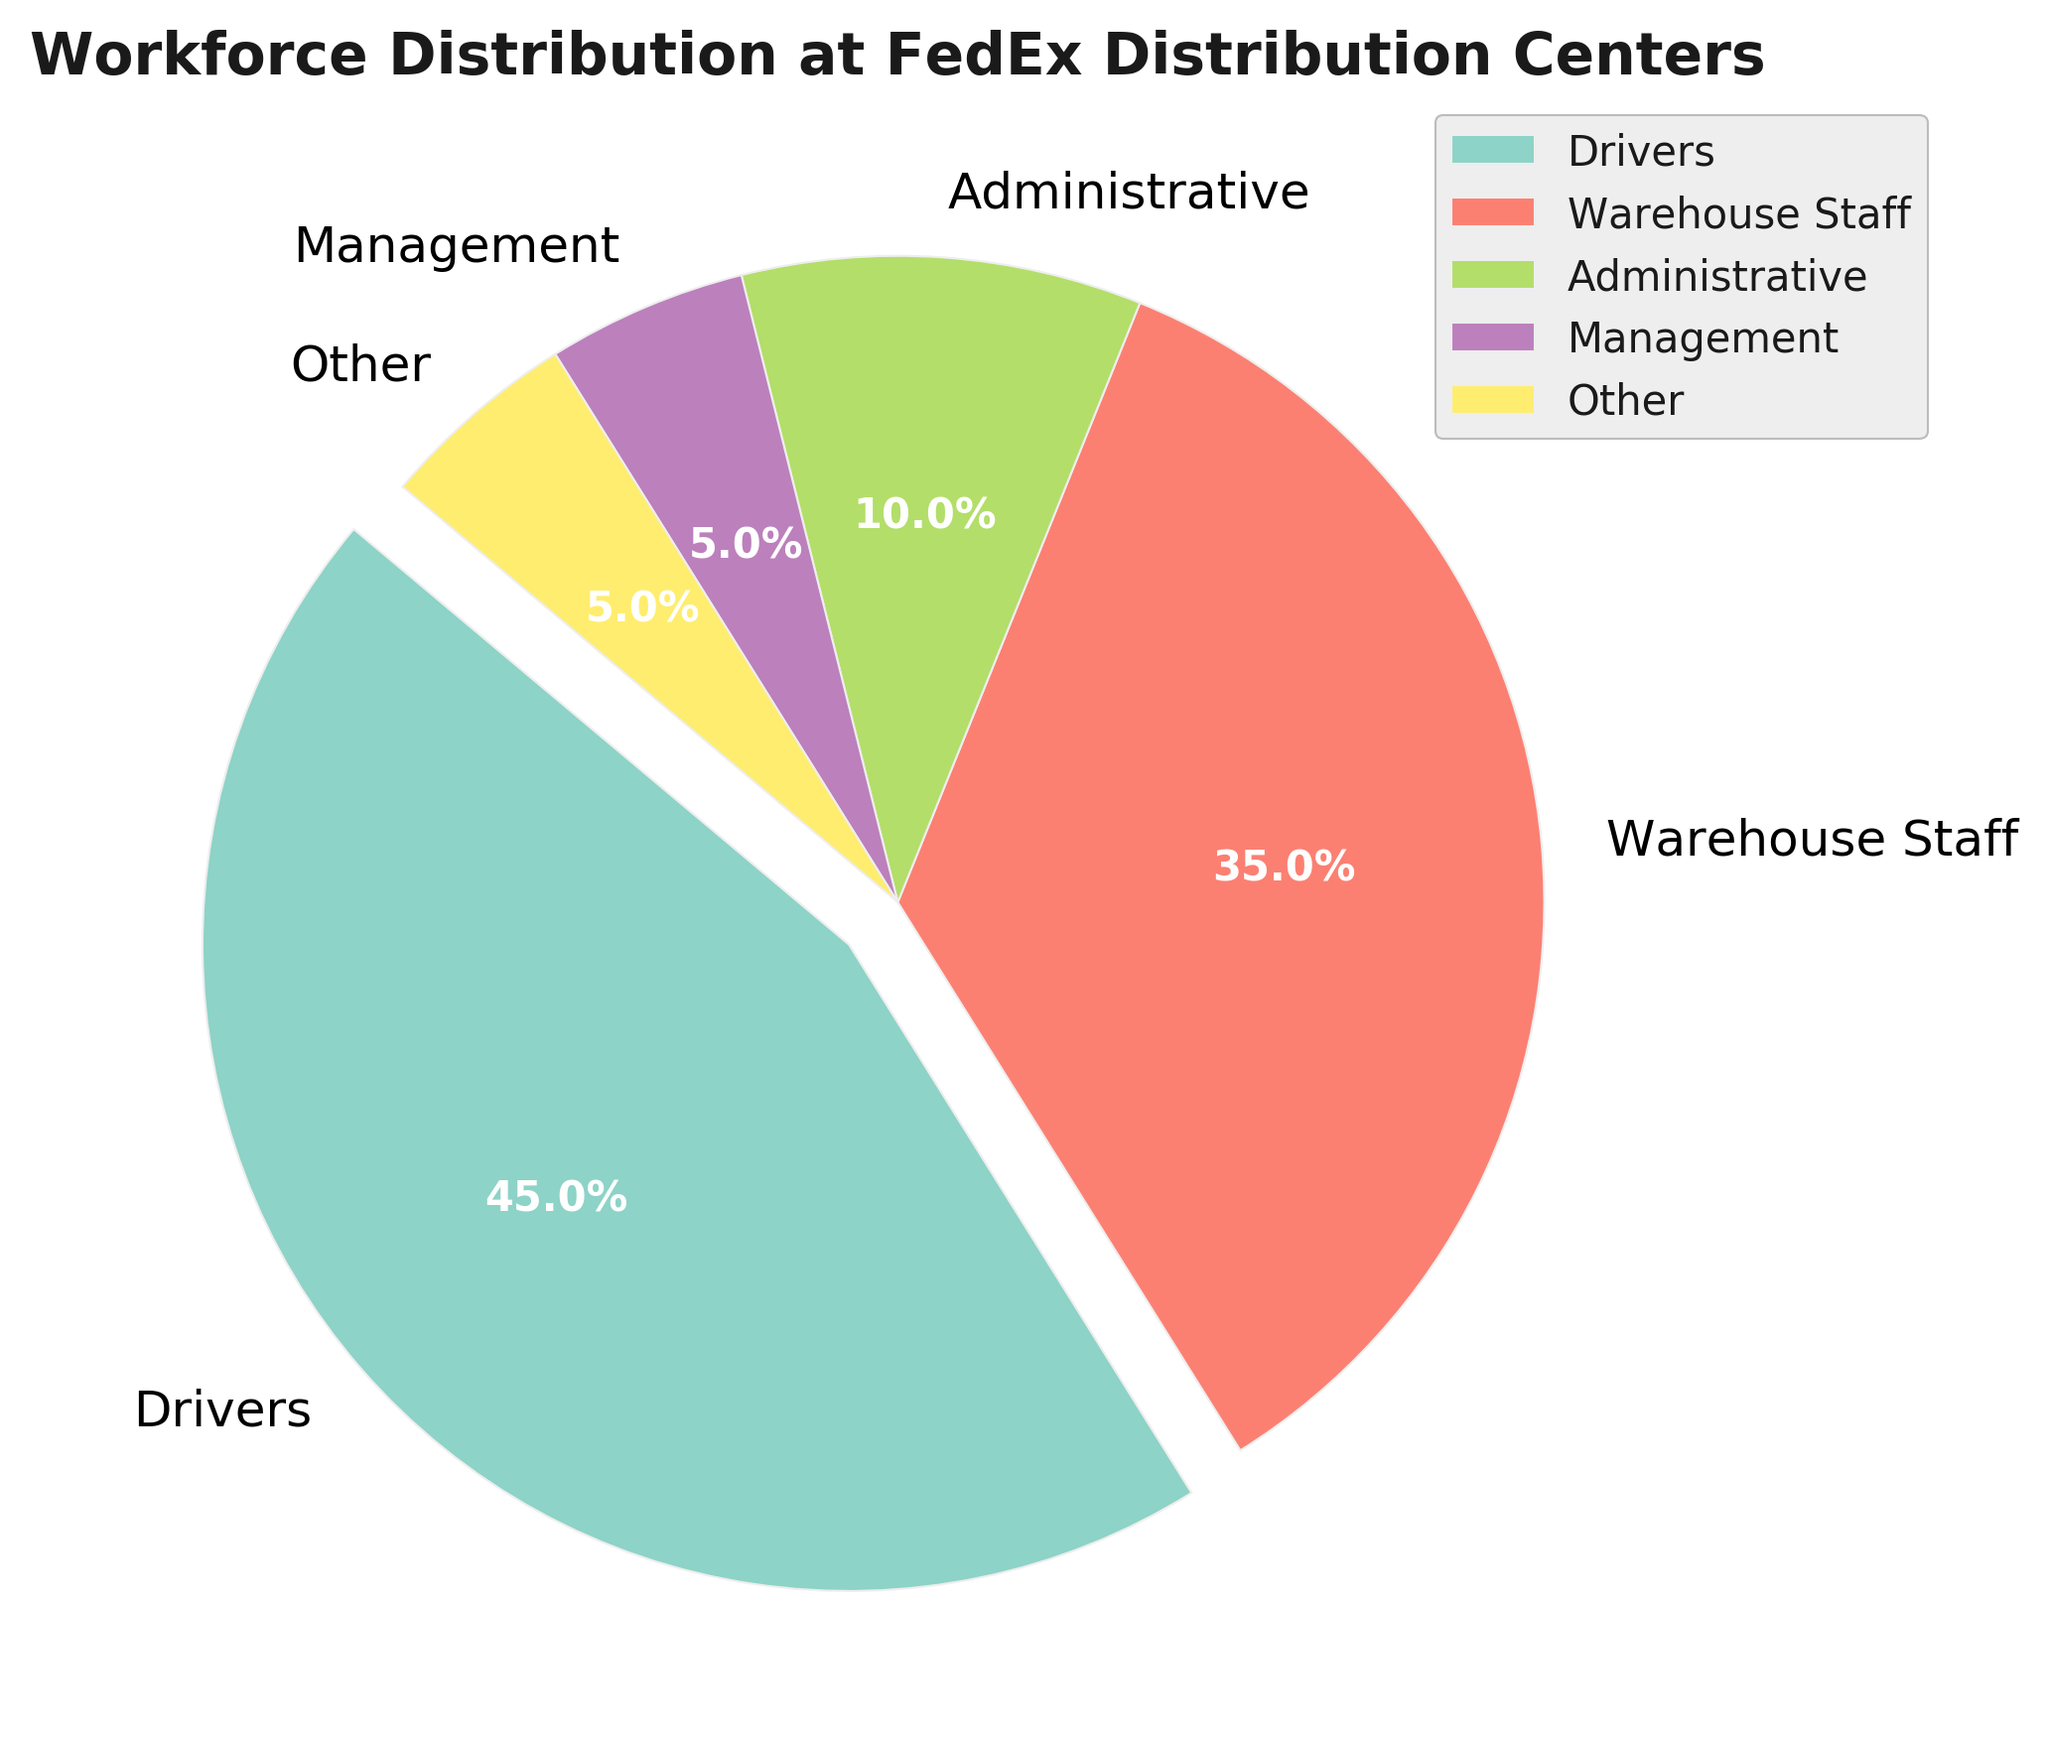What role has the largest percentage of employees? By looking at the pie chart, the segment that is exploding indicates the largest percentage. This segment represents the "Drivers" role.
Answer: Drivers Which role has the smallest number of employees, and what is its percentage? The smallest segment in the pie chart represents the role with the smallest percentage of employees. This is the "Management" role, which accounts for 5%.
Answer: Management, 5% What is the combined percentage of employees in Administrative and Management roles? Add the percentage values of Administrative (10%) and Management (5%) roles. 10% + 5% = 15%.
Answer: 15% How much more percentage do Drivers make up than Warehouse Staff? Subtract the percentage of Warehouse Staff (35%) from the percentage of Drivers (45%). 45% - 35% = 10%.
Answer: 10% Which two roles have the same percentage of employees, and what is that percentage? Identify the segments with equal sizes. Both "Management" and "Other" roles have 5% each.
Answer: Management and Other, 5% What is the total percentage of roles other than Drivers and Warehouse Staff? Subtract the combined percentage of Drivers (45%) and Warehouse Staff (35%) from 100%. 100% - (45% + 35%) = 20%.
Answer: 20% How does the percentage of Administrative employees compare to that of Warehouse Staff? Compare the segments visually. Administrative employees make up 10%, while Warehouse Staff make up 35%. Administrative have a smaller percentage.
Answer: Smaller By what factor is the percentage of Drivers greater than the percentage of Management? Divide the percentage of Drivers (45%) by the percentage of Management (5%). 45 / 5 = 9.
Answer: 9 times Which segment color represents the role with the second-largest percentage of employees? Identify the segment with the second-largest proportion visually. It's the segment for Warehouse Staff, which is often a different unique shade in the pie chart.
Answer: Warehouse Staff Are there any roles that make up exactly one-tenth of the workforce distribution? Visually inspect each segment. The "Administrative" role makes up 10%, which is exactly one-tenth.
Answer: Yes, Administrative 